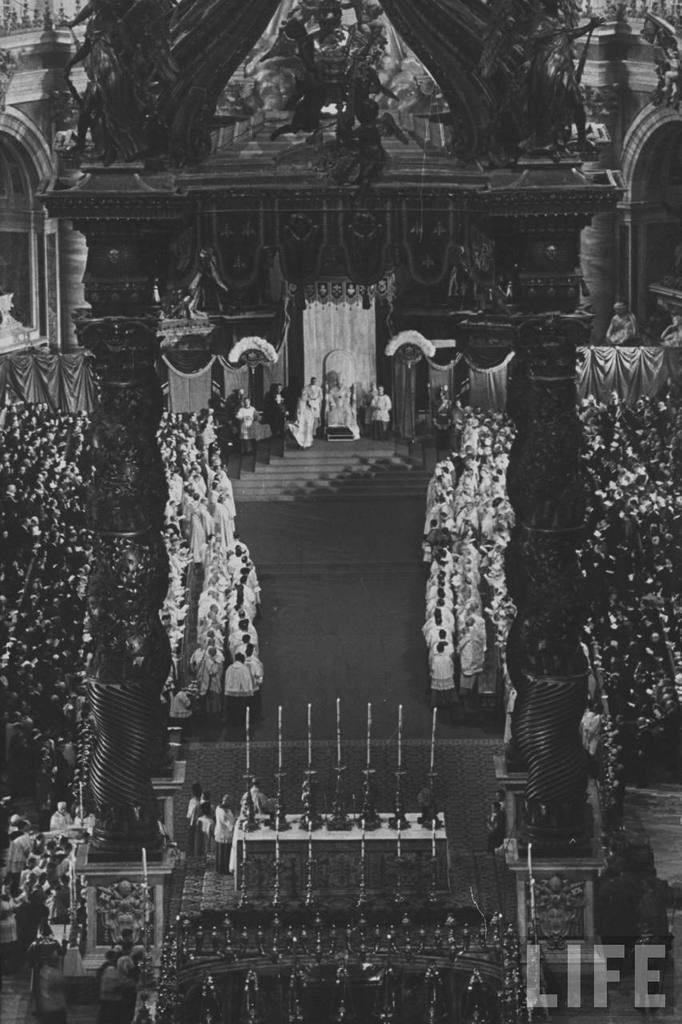How many people are in the image? There is a group of people in the image, but the exact number is not specified. What are the people in the image doing? Some people are standing, and some people are seated. What can be seen in the background of the image? There is an arch and a building in the image. What type of box is being used to store the brains in the image? There is no box or brains present in the image. Can you tell me how many pens are visible in the image? There is no pen visible in the image. 